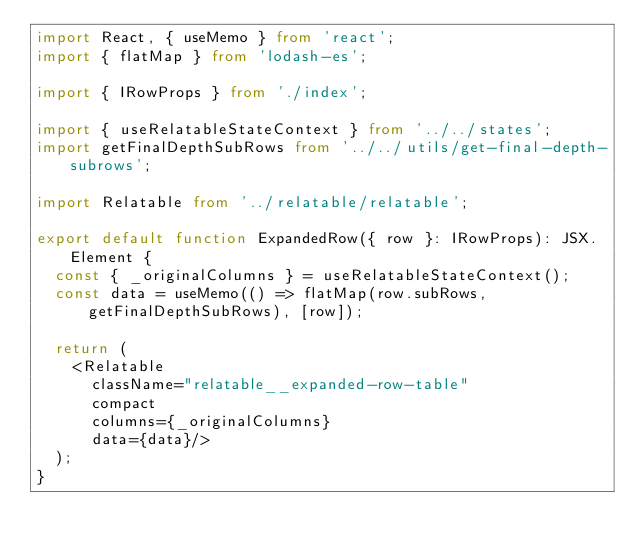<code> <loc_0><loc_0><loc_500><loc_500><_TypeScript_>import React, { useMemo } from 'react';
import { flatMap } from 'lodash-es';

import { IRowProps } from './index';

import { useRelatableStateContext } from '../../states';
import getFinalDepthSubRows from '../../utils/get-final-depth-subrows';

import Relatable from '../relatable/relatable';

export default function ExpandedRow({ row }: IRowProps): JSX.Element {
  const { _originalColumns } = useRelatableStateContext();
  const data = useMemo(() => flatMap(row.subRows, getFinalDepthSubRows), [row]);

  return (
    <Relatable
      className="relatable__expanded-row-table"
      compact
      columns={_originalColumns}
      data={data}/>
  );
}
</code> 